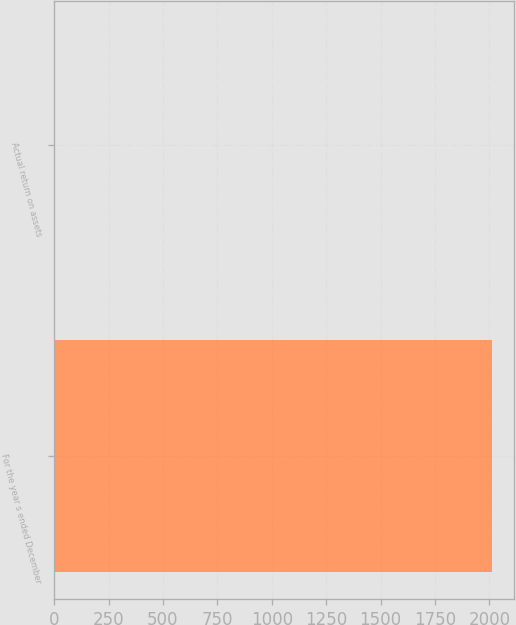<chart> <loc_0><loc_0><loc_500><loc_500><bar_chart><fcel>For the year s ended December<fcel>Actual return on assets<nl><fcel>2011<fcel>0.8<nl></chart> 